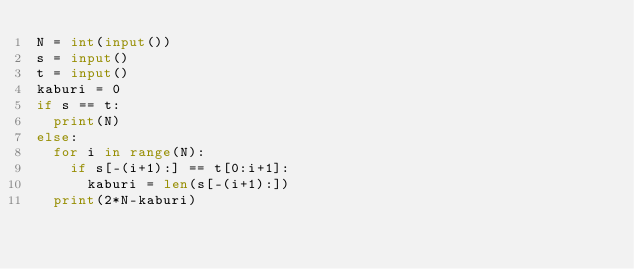<code> <loc_0><loc_0><loc_500><loc_500><_Python_>N = int(input())
s = input()
t = input()
kaburi = 0
if s == t:
  print(N)
else:
  for i in range(N):
    if s[-(i+1):] == t[0:i+1]:
      kaburi = len(s[-(i+1):])
  print(2*N-kaburi)
</code> 